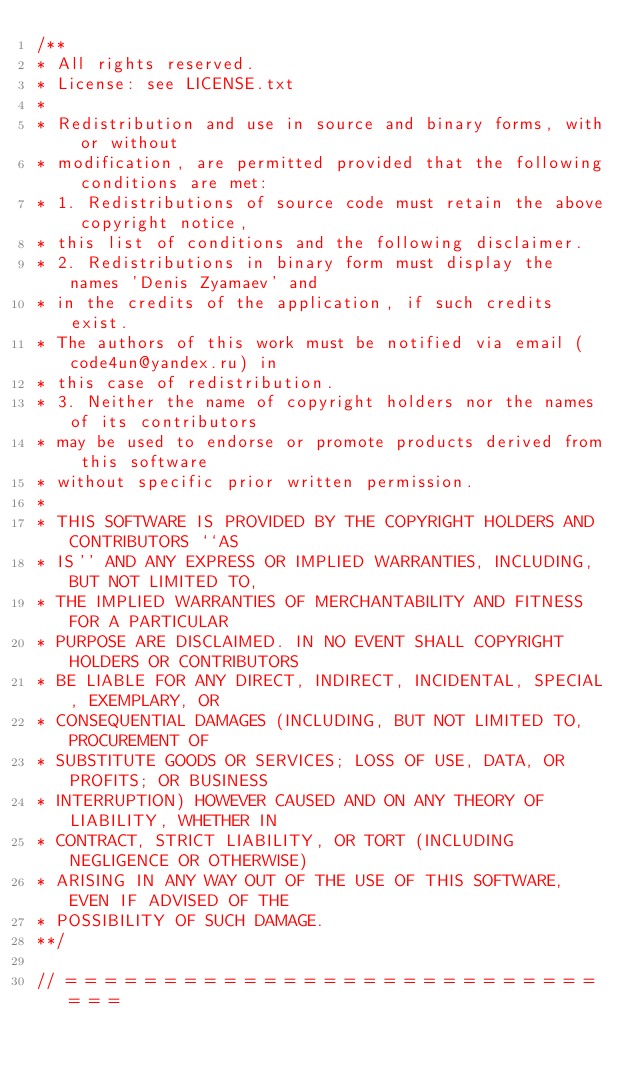Convert code to text. <code><loc_0><loc_0><loc_500><loc_500><_C++_>/**
* All rights reserved.
* License: see LICENSE.txt
*
* Redistribution and use in source and binary forms, with or without
* modification, are permitted provided that the following conditions are met:
* 1. Redistributions of source code must retain the above copyright notice,
* this list of conditions and the following disclaimer.
* 2. Redistributions in binary form must display the names 'Denis Zyamaev' and
* in the credits of the application, if such credits exist.
* The authors of this work must be notified via email (code4un@yandex.ru) in
* this case of redistribution.
* 3. Neither the name of copyright holders nor the names of its contributors
* may be used to endorse or promote products derived from this software
* without specific prior written permission.
*
* THIS SOFTWARE IS PROVIDED BY THE COPYRIGHT HOLDERS AND CONTRIBUTORS ``AS
* IS'' AND ANY EXPRESS OR IMPLIED WARRANTIES, INCLUDING, BUT NOT LIMITED TO,
* THE IMPLIED WARRANTIES OF MERCHANTABILITY AND FITNESS FOR A PARTICULAR
* PURPOSE ARE DISCLAIMED. IN NO EVENT SHALL COPYRIGHT HOLDERS OR CONTRIBUTORS
* BE LIABLE FOR ANY DIRECT, INDIRECT, INCIDENTAL, SPECIAL, EXEMPLARY, OR
* CONSEQUENTIAL DAMAGES (INCLUDING, BUT NOT LIMITED TO, PROCUREMENT OF
* SUBSTITUTE GOODS OR SERVICES; LOSS OF USE, DATA, OR PROFITS; OR BUSINESS
* INTERRUPTION) HOWEVER CAUSED AND ON ANY THEORY OF LIABILITY, WHETHER IN
* CONTRACT, STRICT LIABILITY, OR TORT (INCLUDING NEGLIGENCE OR OTHERWISE)
* ARISING IN ANY WAY OUT OF THE USE OF THIS SOFTWARE, EVEN IF ADVISED OF THE
* POSSIBILITY OF SUCH DAMAGE.
**/

// = = = = = = = = = = = = = = = = = = = = = = = = = = = = = =
</code> 